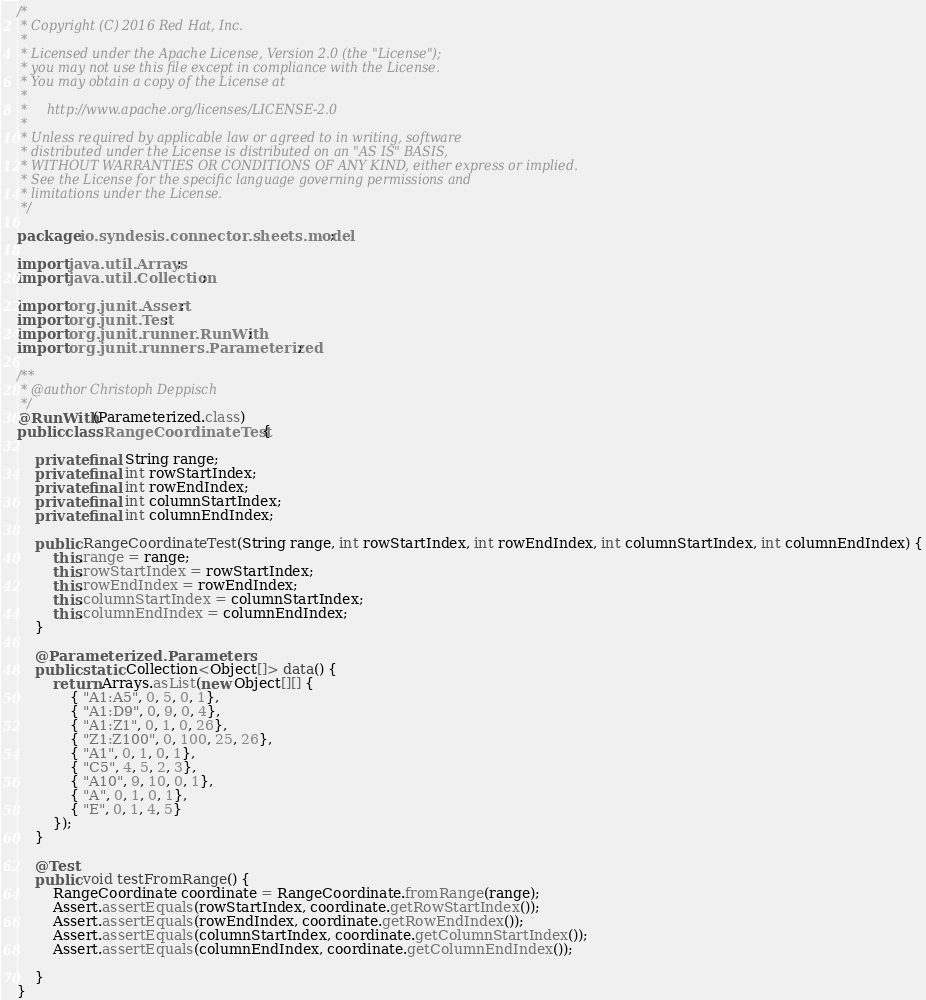Convert code to text. <code><loc_0><loc_0><loc_500><loc_500><_Java_>/*
 * Copyright (C) 2016 Red Hat, Inc.
 *
 * Licensed under the Apache License, Version 2.0 (the "License");
 * you may not use this file except in compliance with the License.
 * You may obtain a copy of the License at
 *
 *     http://www.apache.org/licenses/LICENSE-2.0
 *
 * Unless required by applicable law or agreed to in writing, software
 * distributed under the License is distributed on an "AS IS" BASIS,
 * WITHOUT WARRANTIES OR CONDITIONS OF ANY KIND, either express or implied.
 * See the License for the specific language governing permissions and
 * limitations under the License.
 */

package io.syndesis.connector.sheets.model;

import java.util.Arrays;
import java.util.Collection;

import org.junit.Assert;
import org.junit.Test;
import org.junit.runner.RunWith;
import org.junit.runners.Parameterized;

/**
 * @author Christoph Deppisch
 */
@RunWith(Parameterized.class)
public class RangeCoordinateTest {

    private final String range;
    private final int rowStartIndex;
    private final int rowEndIndex;
    private final int columnStartIndex;
    private final int columnEndIndex;

    public RangeCoordinateTest(String range, int rowStartIndex, int rowEndIndex, int columnStartIndex, int columnEndIndex) {
        this.range = range;
        this.rowStartIndex = rowStartIndex;
        this.rowEndIndex = rowEndIndex;
        this.columnStartIndex = columnStartIndex;
        this.columnEndIndex = columnEndIndex;
    }

    @Parameterized.Parameters
    public static Collection<Object[]> data() {
        return Arrays.asList(new Object[][] {
            { "A1:A5", 0, 5, 0, 1},
            { "A1:D9", 0, 9, 0, 4},
            { "A1:Z1", 0, 1, 0, 26},
            { "Z1:Z100", 0, 100, 25, 26},
            { "A1", 0, 1, 0, 1},
            { "C5", 4, 5, 2, 3},
            { "A10", 9, 10, 0, 1},
            { "A", 0, 1, 0, 1},
            { "E", 0, 1, 4, 5}
        });
    }

    @Test
    public void testFromRange() {
        RangeCoordinate coordinate = RangeCoordinate.fromRange(range);
        Assert.assertEquals(rowStartIndex, coordinate.getRowStartIndex());
        Assert.assertEquals(rowEndIndex, coordinate.getRowEndIndex());
        Assert.assertEquals(columnStartIndex, coordinate.getColumnStartIndex());
        Assert.assertEquals(columnEndIndex, coordinate.getColumnEndIndex());

    }
}
</code> 